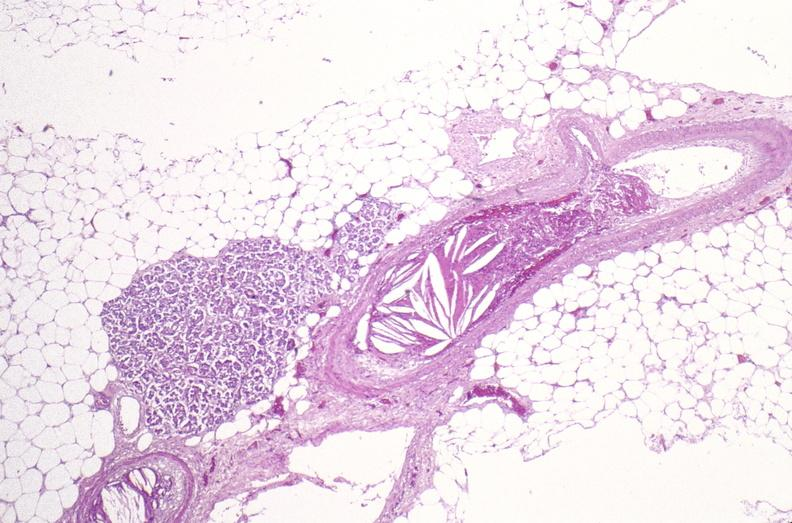s soft tissue present?
Answer the question using a single word or phrase. Yes 